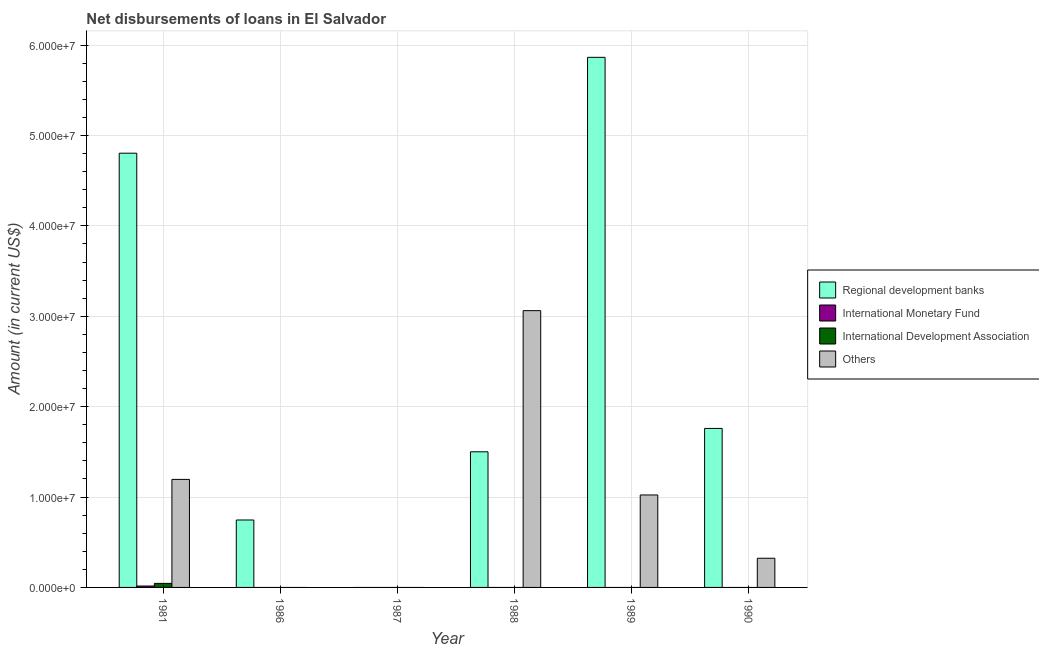How many different coloured bars are there?
Your answer should be compact. 4. Are the number of bars on each tick of the X-axis equal?
Give a very brief answer. No. How many bars are there on the 4th tick from the left?
Ensure brevity in your answer.  2. How many bars are there on the 5th tick from the right?
Provide a succinct answer. 1. What is the label of the 3rd group of bars from the left?
Ensure brevity in your answer.  1987. Across all years, what is the maximum amount of loan disimbursed by regional development banks?
Provide a succinct answer. 5.87e+07. Across all years, what is the minimum amount of loan disimbursed by other organisations?
Your response must be concise. 0. In which year was the amount of loan disimbursed by regional development banks maximum?
Give a very brief answer. 1989. What is the total amount of loan disimbursed by regional development banks in the graph?
Give a very brief answer. 1.47e+08. What is the difference between the amount of loan disimbursed by regional development banks in 1988 and that in 1989?
Make the answer very short. -4.36e+07. What is the difference between the amount of loan disimbursed by international development association in 1989 and the amount of loan disimbursed by other organisations in 1988?
Your response must be concise. 0. What is the average amount of loan disimbursed by international development association per year?
Offer a very short reply. 7.45e+04. In how many years, is the amount of loan disimbursed by international development association greater than 10000000 US$?
Your answer should be compact. 0. What is the ratio of the amount of loan disimbursed by regional development banks in 1981 to that in 1988?
Make the answer very short. 3.2. Is the difference between the amount of loan disimbursed by regional development banks in 1981 and 1989 greater than the difference between the amount of loan disimbursed by international monetary fund in 1981 and 1989?
Make the answer very short. No. What is the difference between the highest and the second highest amount of loan disimbursed by regional development banks?
Your answer should be very brief. 1.06e+07. What is the difference between the highest and the lowest amount of loan disimbursed by other organisations?
Provide a short and direct response. 3.06e+07. In how many years, is the amount of loan disimbursed by international monetary fund greater than the average amount of loan disimbursed by international monetary fund taken over all years?
Ensure brevity in your answer.  1. Are all the bars in the graph horizontal?
Provide a succinct answer. No. What is the difference between two consecutive major ticks on the Y-axis?
Your answer should be compact. 1.00e+07. How many legend labels are there?
Provide a short and direct response. 4. How are the legend labels stacked?
Give a very brief answer. Vertical. What is the title of the graph?
Ensure brevity in your answer.  Net disbursements of loans in El Salvador. Does "Finland" appear as one of the legend labels in the graph?
Keep it short and to the point. No. What is the label or title of the Y-axis?
Your response must be concise. Amount (in current US$). What is the Amount (in current US$) of Regional development banks in 1981?
Make the answer very short. 4.80e+07. What is the Amount (in current US$) of International Monetary Fund in 1981?
Your answer should be compact. 1.56e+05. What is the Amount (in current US$) in International Development Association in 1981?
Ensure brevity in your answer.  4.47e+05. What is the Amount (in current US$) of Others in 1981?
Ensure brevity in your answer.  1.20e+07. What is the Amount (in current US$) in Regional development banks in 1986?
Provide a short and direct response. 7.46e+06. What is the Amount (in current US$) in International Monetary Fund in 1986?
Ensure brevity in your answer.  0. What is the Amount (in current US$) in International Development Association in 1986?
Ensure brevity in your answer.  0. What is the Amount (in current US$) in International Monetary Fund in 1987?
Make the answer very short. 0. What is the Amount (in current US$) in International Development Association in 1987?
Keep it short and to the point. 0. What is the Amount (in current US$) in Regional development banks in 1988?
Your response must be concise. 1.50e+07. What is the Amount (in current US$) in Others in 1988?
Offer a terse response. 3.06e+07. What is the Amount (in current US$) in Regional development banks in 1989?
Give a very brief answer. 5.87e+07. What is the Amount (in current US$) of International Development Association in 1989?
Keep it short and to the point. 0. What is the Amount (in current US$) in Others in 1989?
Give a very brief answer. 1.02e+07. What is the Amount (in current US$) in Regional development banks in 1990?
Keep it short and to the point. 1.76e+07. What is the Amount (in current US$) in International Monetary Fund in 1990?
Offer a terse response. 0. What is the Amount (in current US$) in Others in 1990?
Make the answer very short. 3.23e+06. Across all years, what is the maximum Amount (in current US$) of Regional development banks?
Provide a short and direct response. 5.87e+07. Across all years, what is the maximum Amount (in current US$) of International Monetary Fund?
Make the answer very short. 1.56e+05. Across all years, what is the maximum Amount (in current US$) in International Development Association?
Offer a very short reply. 4.47e+05. Across all years, what is the maximum Amount (in current US$) in Others?
Provide a succinct answer. 3.06e+07. Across all years, what is the minimum Amount (in current US$) of International Monetary Fund?
Offer a terse response. 0. Across all years, what is the minimum Amount (in current US$) in International Development Association?
Offer a terse response. 0. Across all years, what is the minimum Amount (in current US$) of Others?
Your answer should be compact. 0. What is the total Amount (in current US$) of Regional development banks in the graph?
Provide a succinct answer. 1.47e+08. What is the total Amount (in current US$) in International Monetary Fund in the graph?
Keep it short and to the point. 1.56e+05. What is the total Amount (in current US$) of International Development Association in the graph?
Offer a very short reply. 4.47e+05. What is the total Amount (in current US$) in Others in the graph?
Make the answer very short. 5.60e+07. What is the difference between the Amount (in current US$) in Regional development banks in 1981 and that in 1986?
Give a very brief answer. 4.06e+07. What is the difference between the Amount (in current US$) in Regional development banks in 1981 and that in 1988?
Give a very brief answer. 3.30e+07. What is the difference between the Amount (in current US$) in Others in 1981 and that in 1988?
Make the answer very short. -1.87e+07. What is the difference between the Amount (in current US$) of Regional development banks in 1981 and that in 1989?
Give a very brief answer. -1.06e+07. What is the difference between the Amount (in current US$) in Others in 1981 and that in 1989?
Offer a very short reply. 1.72e+06. What is the difference between the Amount (in current US$) in Regional development banks in 1981 and that in 1990?
Ensure brevity in your answer.  3.05e+07. What is the difference between the Amount (in current US$) of Others in 1981 and that in 1990?
Keep it short and to the point. 8.72e+06. What is the difference between the Amount (in current US$) of Regional development banks in 1986 and that in 1988?
Keep it short and to the point. -7.54e+06. What is the difference between the Amount (in current US$) in Regional development banks in 1986 and that in 1989?
Your response must be concise. -5.12e+07. What is the difference between the Amount (in current US$) of Regional development banks in 1986 and that in 1990?
Give a very brief answer. -1.01e+07. What is the difference between the Amount (in current US$) in Regional development banks in 1988 and that in 1989?
Provide a short and direct response. -4.36e+07. What is the difference between the Amount (in current US$) of Others in 1988 and that in 1989?
Offer a terse response. 2.04e+07. What is the difference between the Amount (in current US$) in Regional development banks in 1988 and that in 1990?
Ensure brevity in your answer.  -2.59e+06. What is the difference between the Amount (in current US$) of Others in 1988 and that in 1990?
Your answer should be compact. 2.74e+07. What is the difference between the Amount (in current US$) of Regional development banks in 1989 and that in 1990?
Give a very brief answer. 4.11e+07. What is the difference between the Amount (in current US$) of Others in 1989 and that in 1990?
Keep it short and to the point. 7.00e+06. What is the difference between the Amount (in current US$) of Regional development banks in 1981 and the Amount (in current US$) of Others in 1988?
Make the answer very short. 1.74e+07. What is the difference between the Amount (in current US$) in International Monetary Fund in 1981 and the Amount (in current US$) in Others in 1988?
Keep it short and to the point. -3.05e+07. What is the difference between the Amount (in current US$) in International Development Association in 1981 and the Amount (in current US$) in Others in 1988?
Provide a succinct answer. -3.02e+07. What is the difference between the Amount (in current US$) of Regional development banks in 1981 and the Amount (in current US$) of Others in 1989?
Provide a succinct answer. 3.78e+07. What is the difference between the Amount (in current US$) in International Monetary Fund in 1981 and the Amount (in current US$) in Others in 1989?
Make the answer very short. -1.01e+07. What is the difference between the Amount (in current US$) in International Development Association in 1981 and the Amount (in current US$) in Others in 1989?
Keep it short and to the point. -9.78e+06. What is the difference between the Amount (in current US$) of Regional development banks in 1981 and the Amount (in current US$) of Others in 1990?
Provide a succinct answer. 4.48e+07. What is the difference between the Amount (in current US$) of International Monetary Fund in 1981 and the Amount (in current US$) of Others in 1990?
Provide a short and direct response. -3.07e+06. What is the difference between the Amount (in current US$) of International Development Association in 1981 and the Amount (in current US$) of Others in 1990?
Keep it short and to the point. -2.78e+06. What is the difference between the Amount (in current US$) in Regional development banks in 1986 and the Amount (in current US$) in Others in 1988?
Give a very brief answer. -2.32e+07. What is the difference between the Amount (in current US$) of Regional development banks in 1986 and the Amount (in current US$) of Others in 1989?
Keep it short and to the point. -2.77e+06. What is the difference between the Amount (in current US$) of Regional development banks in 1986 and the Amount (in current US$) of Others in 1990?
Offer a very short reply. 4.23e+06. What is the difference between the Amount (in current US$) in Regional development banks in 1988 and the Amount (in current US$) in Others in 1989?
Provide a succinct answer. 4.78e+06. What is the difference between the Amount (in current US$) of Regional development banks in 1988 and the Amount (in current US$) of Others in 1990?
Provide a succinct answer. 1.18e+07. What is the difference between the Amount (in current US$) in Regional development banks in 1989 and the Amount (in current US$) in Others in 1990?
Keep it short and to the point. 5.54e+07. What is the average Amount (in current US$) in Regional development banks per year?
Offer a very short reply. 2.45e+07. What is the average Amount (in current US$) of International Monetary Fund per year?
Your response must be concise. 2.60e+04. What is the average Amount (in current US$) in International Development Association per year?
Your response must be concise. 7.45e+04. What is the average Amount (in current US$) in Others per year?
Provide a short and direct response. 9.34e+06. In the year 1981, what is the difference between the Amount (in current US$) in Regional development banks and Amount (in current US$) in International Monetary Fund?
Offer a very short reply. 4.79e+07. In the year 1981, what is the difference between the Amount (in current US$) in Regional development banks and Amount (in current US$) in International Development Association?
Provide a short and direct response. 4.76e+07. In the year 1981, what is the difference between the Amount (in current US$) in Regional development banks and Amount (in current US$) in Others?
Keep it short and to the point. 3.61e+07. In the year 1981, what is the difference between the Amount (in current US$) in International Monetary Fund and Amount (in current US$) in International Development Association?
Your answer should be compact. -2.91e+05. In the year 1981, what is the difference between the Amount (in current US$) of International Monetary Fund and Amount (in current US$) of Others?
Give a very brief answer. -1.18e+07. In the year 1981, what is the difference between the Amount (in current US$) of International Development Association and Amount (in current US$) of Others?
Ensure brevity in your answer.  -1.15e+07. In the year 1988, what is the difference between the Amount (in current US$) of Regional development banks and Amount (in current US$) of Others?
Your answer should be very brief. -1.56e+07. In the year 1989, what is the difference between the Amount (in current US$) in Regional development banks and Amount (in current US$) in Others?
Offer a terse response. 4.84e+07. In the year 1990, what is the difference between the Amount (in current US$) in Regional development banks and Amount (in current US$) in Others?
Your answer should be compact. 1.44e+07. What is the ratio of the Amount (in current US$) of Regional development banks in 1981 to that in 1986?
Provide a succinct answer. 6.44. What is the ratio of the Amount (in current US$) in Regional development banks in 1981 to that in 1988?
Your response must be concise. 3.2. What is the ratio of the Amount (in current US$) in Others in 1981 to that in 1988?
Provide a short and direct response. 0.39. What is the ratio of the Amount (in current US$) of Regional development banks in 1981 to that in 1989?
Offer a terse response. 0.82. What is the ratio of the Amount (in current US$) of Others in 1981 to that in 1989?
Offer a terse response. 1.17. What is the ratio of the Amount (in current US$) of Regional development banks in 1981 to that in 1990?
Offer a very short reply. 2.73. What is the ratio of the Amount (in current US$) in Others in 1981 to that in 1990?
Offer a terse response. 3.7. What is the ratio of the Amount (in current US$) of Regional development banks in 1986 to that in 1988?
Your response must be concise. 0.5. What is the ratio of the Amount (in current US$) of Regional development banks in 1986 to that in 1989?
Offer a very short reply. 0.13. What is the ratio of the Amount (in current US$) in Regional development banks in 1986 to that in 1990?
Your answer should be very brief. 0.42. What is the ratio of the Amount (in current US$) in Regional development banks in 1988 to that in 1989?
Make the answer very short. 0.26. What is the ratio of the Amount (in current US$) of Others in 1988 to that in 1989?
Your response must be concise. 2.99. What is the ratio of the Amount (in current US$) of Regional development banks in 1988 to that in 1990?
Provide a succinct answer. 0.85. What is the ratio of the Amount (in current US$) of Others in 1988 to that in 1990?
Your response must be concise. 9.48. What is the ratio of the Amount (in current US$) of Regional development banks in 1989 to that in 1990?
Offer a very short reply. 3.33. What is the ratio of the Amount (in current US$) in Others in 1989 to that in 1990?
Provide a short and direct response. 3.17. What is the difference between the highest and the second highest Amount (in current US$) of Regional development banks?
Make the answer very short. 1.06e+07. What is the difference between the highest and the second highest Amount (in current US$) in Others?
Give a very brief answer. 1.87e+07. What is the difference between the highest and the lowest Amount (in current US$) in Regional development banks?
Make the answer very short. 5.87e+07. What is the difference between the highest and the lowest Amount (in current US$) of International Monetary Fund?
Provide a succinct answer. 1.56e+05. What is the difference between the highest and the lowest Amount (in current US$) of International Development Association?
Your answer should be compact. 4.47e+05. What is the difference between the highest and the lowest Amount (in current US$) of Others?
Your answer should be very brief. 3.06e+07. 